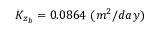<formula> <loc_0><loc_0><loc_500><loc_500>K _ { z _ { b } } = 0 . 0 8 6 4 ( m ^ { 2 } / d a y )</formula> 